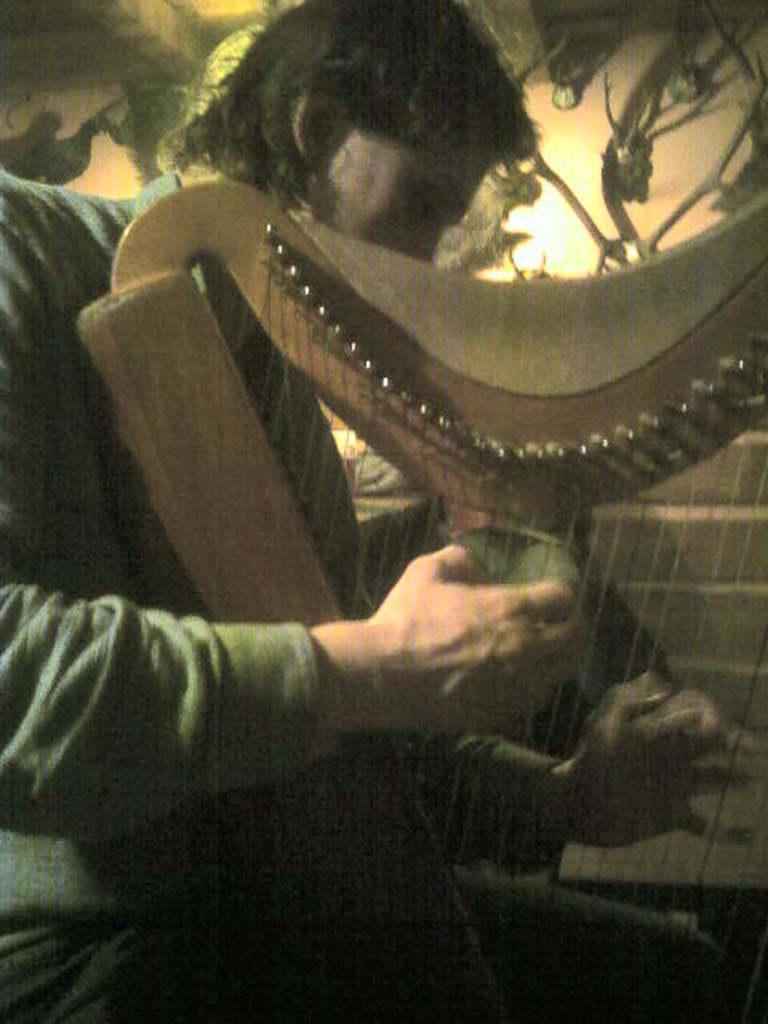What is the main subject of the image? There is a person in the image. What is the person doing in the image? The person is playing a musical instrument. What can be seen in the background of the image? There is a wall in the background of the image. Can you describe the lighting in the image? There is a light visible in the image. How many rabbits are jumping over the needle in the image? There are no rabbits or needles present in the image. 